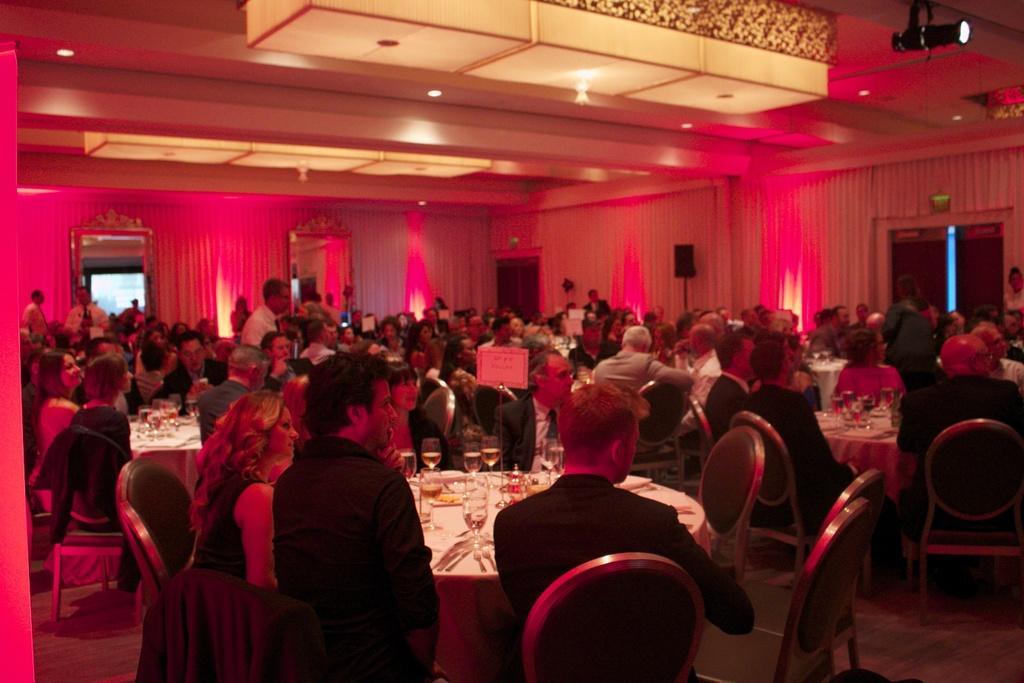Describe this image in one or two sentences. In this image I see number of people who are sitting on chairs and there are tables in front of them, on which there are many things. I see that few people are standing. In the background I see the wall, doors and lights on the ceiling. 